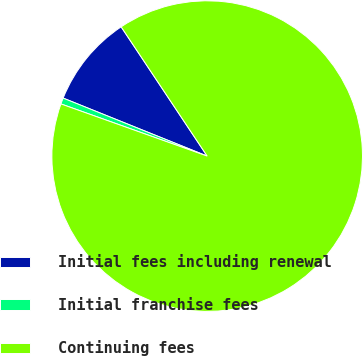<chart> <loc_0><loc_0><loc_500><loc_500><pie_chart><fcel>Initial fees including renewal<fcel>Initial franchise fees<fcel>Continuing fees<nl><fcel>9.56%<fcel>0.64%<fcel>89.8%<nl></chart> 